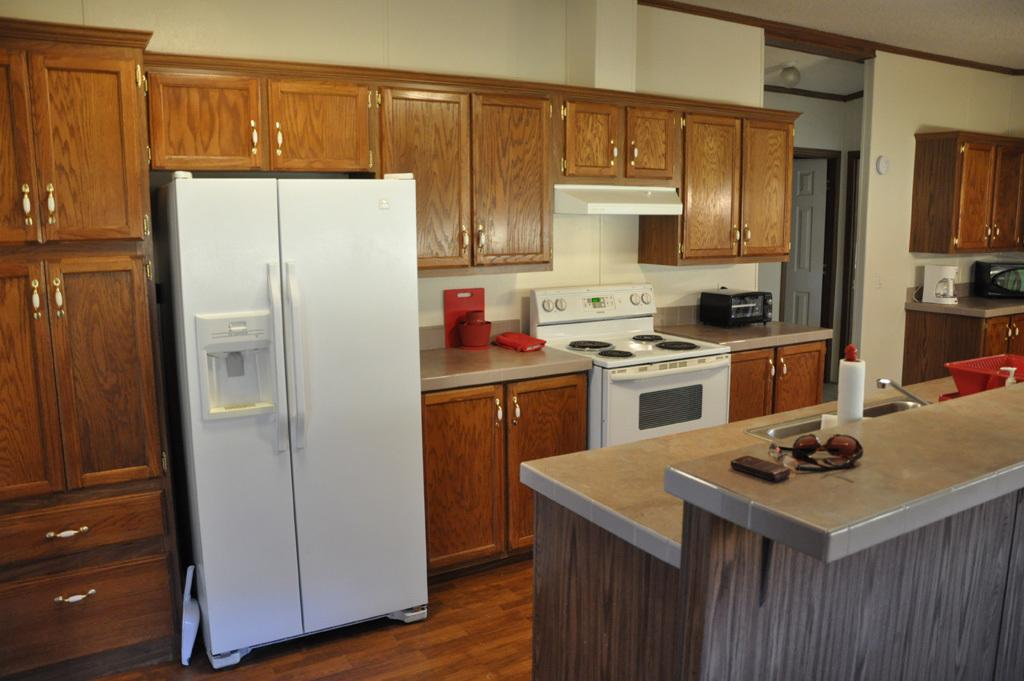What type of appliance can be seen in the image? There is a fridge, a stove, and an oven in the image. What is used for washing in the image? There is a sink with a tap in the image. What can be found on the countertops in the image? There are objects on the countertops in the image. What is the color of the cupboards in the image? The cupboards in the image are brown. What architectural features are present in the image? There is a door and a wall in the image. Can you tell me how many zippers are on the fridge in the image? There are no zippers present on the fridge or any other appliance in the image. What type of burn is visible on the stove in the image? There is no burn visible on the stove or any other appliance in the image. 